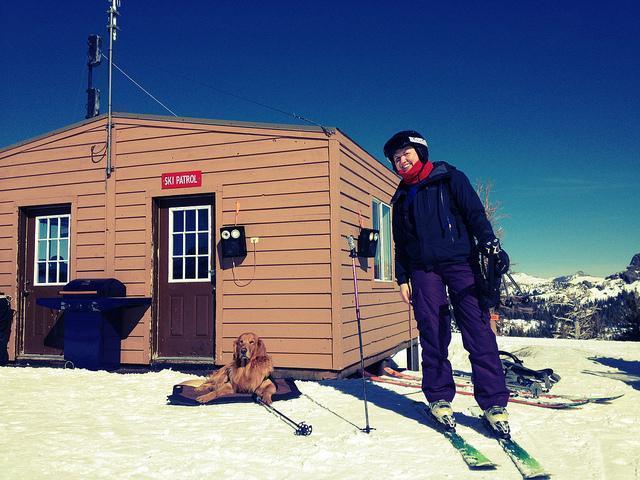How many giraffes are drinking from the water?
Give a very brief answer. 0. 